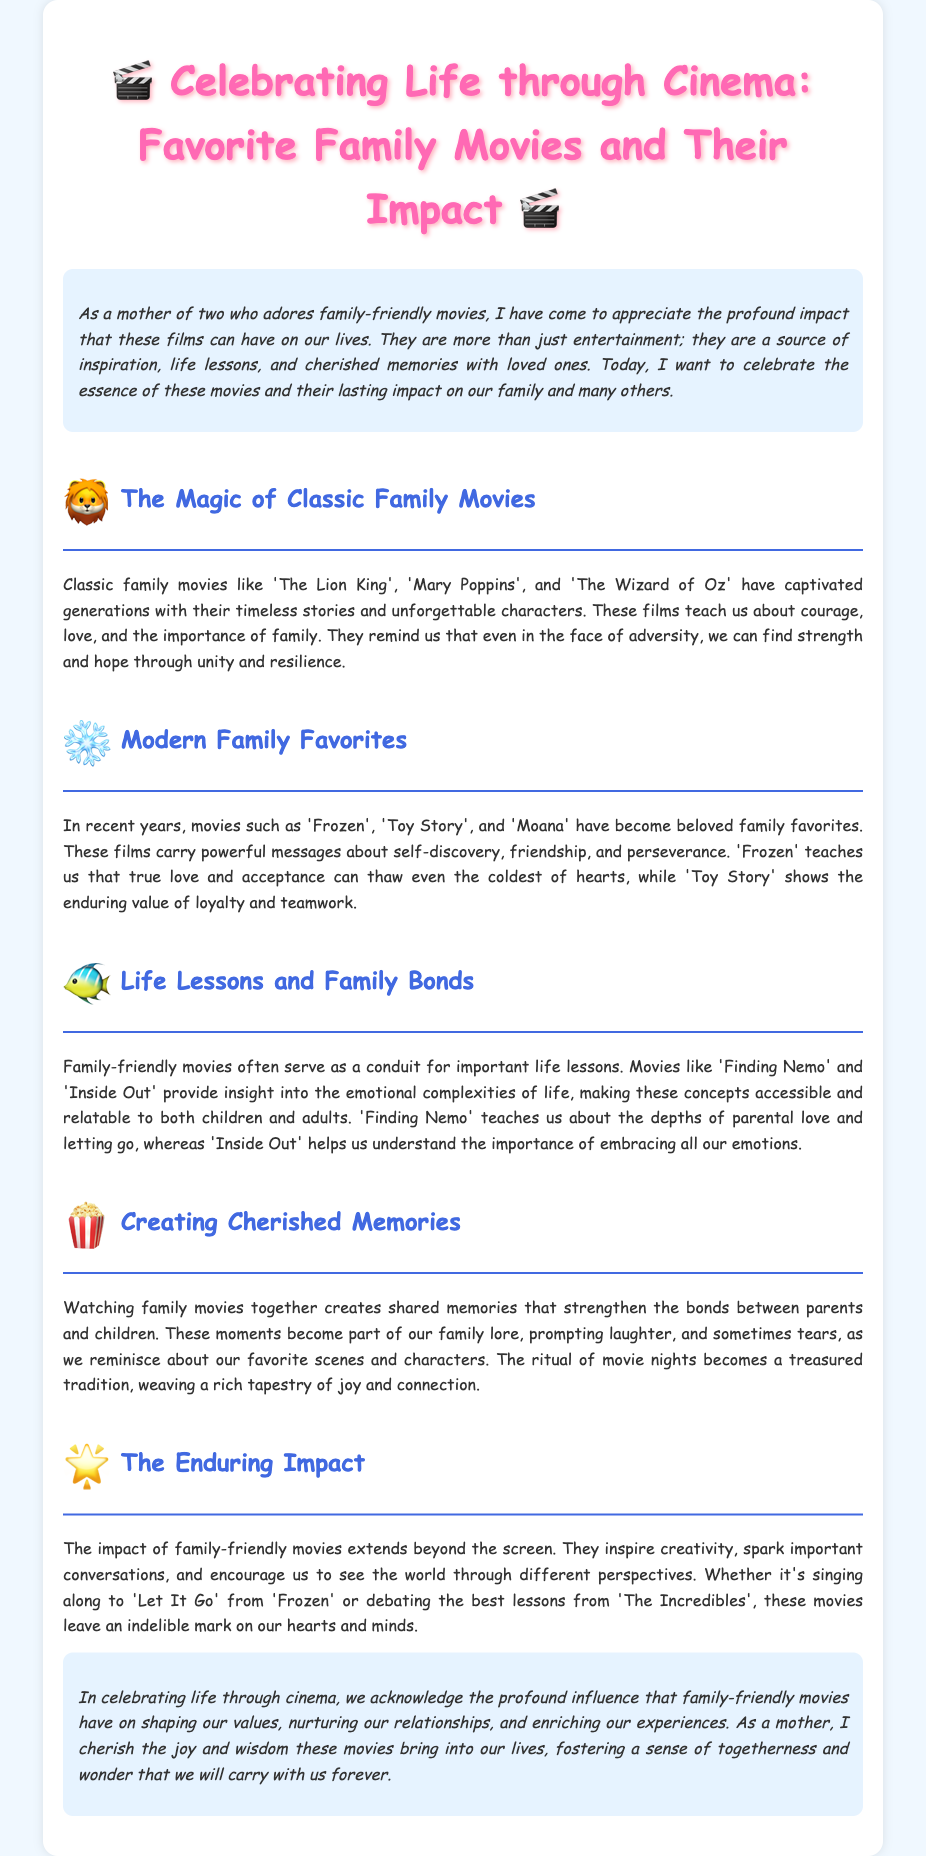What is the title of the eulogy? The title of the eulogy is found in the header section.
Answer: Celebrating Life through Cinema: Favorite Family Movies and Their Impact Who is the targeted audience of the eulogy? The introduction specifies the audience as a mother of two who adores family-friendly movies.
Answer: A mother of two Name one classic family movie mentioned. The section on classic family movies lists titles that are well-known.
Answer: The Lion King What lesson does 'Inside Out' help us understand? The document provides insights into the lessons learned from various movies.
Answer: Importance of embracing all our emotions What is a cherished tradition mentioned in the eulogy? The eulogy describes activities that families partake in together.
Answer: Movie nights Which film teaches about parental love and letting go? The section discussing life lessons identifies specific movies and their messages.
Answer: Finding Nemo What emotion does 'Frozen' convey regarding love? The explanation regarding 'Frozen' highlights the film's central theme.
Answer: True love and acceptance What do family movies inspire according to the eulogy? The section discusses the broader impacts of family-friendly movies.
Answer: Creativity What impact do family-friendly movies have on relationships? The conclusion addresses the overall effect of these films on family connections.
Answer: Nurturing relationships 